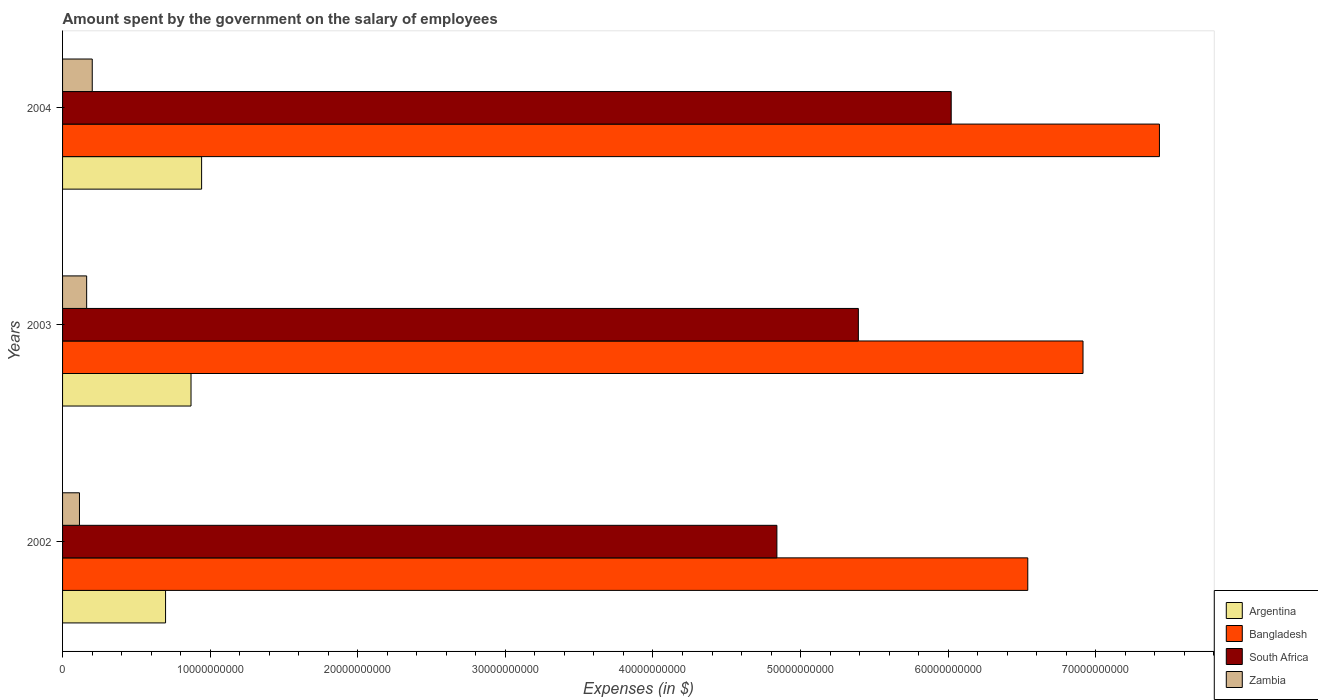How many groups of bars are there?
Keep it short and to the point. 3. Are the number of bars on each tick of the Y-axis equal?
Provide a short and direct response. Yes. How many bars are there on the 2nd tick from the bottom?
Your answer should be very brief. 4. In how many cases, is the number of bars for a given year not equal to the number of legend labels?
Offer a terse response. 0. What is the amount spent on the salary of employees by the government in Zambia in 2004?
Make the answer very short. 2.01e+09. Across all years, what is the maximum amount spent on the salary of employees by the government in Zambia?
Your answer should be very brief. 2.01e+09. Across all years, what is the minimum amount spent on the salary of employees by the government in Zambia?
Keep it short and to the point. 1.15e+09. In which year was the amount spent on the salary of employees by the government in South Africa maximum?
Provide a succinct answer. 2004. In which year was the amount spent on the salary of employees by the government in South Africa minimum?
Ensure brevity in your answer.  2002. What is the total amount spent on the salary of employees by the government in Argentina in the graph?
Your answer should be compact. 2.51e+1. What is the difference between the amount spent on the salary of employees by the government in Zambia in 2002 and that in 2003?
Your response must be concise. -4.87e+08. What is the difference between the amount spent on the salary of employees by the government in Argentina in 2004 and the amount spent on the salary of employees by the government in Zambia in 2002?
Your answer should be very brief. 8.27e+09. What is the average amount spent on the salary of employees by the government in Bangladesh per year?
Offer a terse response. 6.96e+1. In the year 2004, what is the difference between the amount spent on the salary of employees by the government in Zambia and amount spent on the salary of employees by the government in Argentina?
Your response must be concise. -7.41e+09. What is the ratio of the amount spent on the salary of employees by the government in South Africa in 2002 to that in 2004?
Provide a succinct answer. 0.8. What is the difference between the highest and the second highest amount spent on the salary of employees by the government in Argentina?
Your answer should be compact. 7.17e+08. What is the difference between the highest and the lowest amount spent on the salary of employees by the government in South Africa?
Keep it short and to the point. 1.18e+1. What does the 4th bar from the top in 2003 represents?
Provide a short and direct response. Argentina. What does the 1st bar from the bottom in 2004 represents?
Your answer should be compact. Argentina. Is it the case that in every year, the sum of the amount spent on the salary of employees by the government in Argentina and amount spent on the salary of employees by the government in South Africa is greater than the amount spent on the salary of employees by the government in Bangladesh?
Provide a succinct answer. No. How many bars are there?
Your response must be concise. 12. How many years are there in the graph?
Your answer should be very brief. 3. What is the difference between two consecutive major ticks on the X-axis?
Keep it short and to the point. 1.00e+1. Are the values on the major ticks of X-axis written in scientific E-notation?
Ensure brevity in your answer.  No. Does the graph contain any zero values?
Give a very brief answer. No. Does the graph contain grids?
Provide a short and direct response. No. How are the legend labels stacked?
Offer a terse response. Vertical. What is the title of the graph?
Your answer should be compact. Amount spent by the government on the salary of employees. Does "Guinea-Bissau" appear as one of the legend labels in the graph?
Your response must be concise. No. What is the label or title of the X-axis?
Provide a short and direct response. Expenses (in $). What is the Expenses (in $) in Argentina in 2002?
Provide a succinct answer. 6.98e+09. What is the Expenses (in $) of Bangladesh in 2002?
Provide a short and direct response. 6.54e+1. What is the Expenses (in $) in South Africa in 2002?
Offer a terse response. 4.84e+1. What is the Expenses (in $) in Zambia in 2002?
Give a very brief answer. 1.15e+09. What is the Expenses (in $) of Argentina in 2003?
Provide a short and direct response. 8.70e+09. What is the Expenses (in $) in Bangladesh in 2003?
Ensure brevity in your answer.  6.91e+1. What is the Expenses (in $) of South Africa in 2003?
Offer a very short reply. 5.39e+1. What is the Expenses (in $) in Zambia in 2003?
Make the answer very short. 1.63e+09. What is the Expenses (in $) in Argentina in 2004?
Your answer should be compact. 9.42e+09. What is the Expenses (in $) in Bangladesh in 2004?
Ensure brevity in your answer.  7.43e+1. What is the Expenses (in $) of South Africa in 2004?
Make the answer very short. 6.02e+1. What is the Expenses (in $) of Zambia in 2004?
Keep it short and to the point. 2.01e+09. Across all years, what is the maximum Expenses (in $) of Argentina?
Offer a very short reply. 9.42e+09. Across all years, what is the maximum Expenses (in $) of Bangladesh?
Ensure brevity in your answer.  7.43e+1. Across all years, what is the maximum Expenses (in $) in South Africa?
Give a very brief answer. 6.02e+1. Across all years, what is the maximum Expenses (in $) in Zambia?
Your answer should be very brief. 2.01e+09. Across all years, what is the minimum Expenses (in $) in Argentina?
Make the answer very short. 6.98e+09. Across all years, what is the minimum Expenses (in $) in Bangladesh?
Provide a short and direct response. 6.54e+1. Across all years, what is the minimum Expenses (in $) in South Africa?
Offer a very short reply. 4.84e+1. Across all years, what is the minimum Expenses (in $) in Zambia?
Ensure brevity in your answer.  1.15e+09. What is the total Expenses (in $) in Argentina in the graph?
Offer a terse response. 2.51e+1. What is the total Expenses (in $) of Bangladesh in the graph?
Provide a succinct answer. 2.09e+11. What is the total Expenses (in $) in South Africa in the graph?
Make the answer very short. 1.63e+11. What is the total Expenses (in $) of Zambia in the graph?
Give a very brief answer. 4.79e+09. What is the difference between the Expenses (in $) of Argentina in 2002 and that in 2003?
Offer a terse response. -1.72e+09. What is the difference between the Expenses (in $) in Bangladesh in 2002 and that in 2003?
Keep it short and to the point. -3.74e+09. What is the difference between the Expenses (in $) of South Africa in 2002 and that in 2003?
Keep it short and to the point. -5.52e+09. What is the difference between the Expenses (in $) of Zambia in 2002 and that in 2003?
Provide a short and direct response. -4.87e+08. What is the difference between the Expenses (in $) in Argentina in 2002 and that in 2004?
Your answer should be compact. -2.44e+09. What is the difference between the Expenses (in $) of Bangladesh in 2002 and that in 2004?
Provide a short and direct response. -8.92e+09. What is the difference between the Expenses (in $) of South Africa in 2002 and that in 2004?
Provide a short and direct response. -1.18e+1. What is the difference between the Expenses (in $) of Zambia in 2002 and that in 2004?
Offer a very short reply. -8.65e+08. What is the difference between the Expenses (in $) of Argentina in 2003 and that in 2004?
Provide a short and direct response. -7.17e+08. What is the difference between the Expenses (in $) of Bangladesh in 2003 and that in 2004?
Offer a very short reply. -5.18e+09. What is the difference between the Expenses (in $) in South Africa in 2003 and that in 2004?
Your answer should be compact. -6.29e+09. What is the difference between the Expenses (in $) in Zambia in 2003 and that in 2004?
Provide a succinct answer. -3.78e+08. What is the difference between the Expenses (in $) in Argentina in 2002 and the Expenses (in $) in Bangladesh in 2003?
Ensure brevity in your answer.  -6.22e+1. What is the difference between the Expenses (in $) of Argentina in 2002 and the Expenses (in $) of South Africa in 2003?
Offer a terse response. -4.69e+1. What is the difference between the Expenses (in $) of Argentina in 2002 and the Expenses (in $) of Zambia in 2003?
Offer a terse response. 5.35e+09. What is the difference between the Expenses (in $) in Bangladesh in 2002 and the Expenses (in $) in South Africa in 2003?
Give a very brief answer. 1.15e+1. What is the difference between the Expenses (in $) of Bangladesh in 2002 and the Expenses (in $) of Zambia in 2003?
Give a very brief answer. 6.38e+1. What is the difference between the Expenses (in $) of South Africa in 2002 and the Expenses (in $) of Zambia in 2003?
Ensure brevity in your answer.  4.68e+1. What is the difference between the Expenses (in $) of Argentina in 2002 and the Expenses (in $) of Bangladesh in 2004?
Your response must be concise. -6.73e+1. What is the difference between the Expenses (in $) in Argentina in 2002 and the Expenses (in $) in South Africa in 2004?
Give a very brief answer. -5.32e+1. What is the difference between the Expenses (in $) in Argentina in 2002 and the Expenses (in $) in Zambia in 2004?
Ensure brevity in your answer.  4.97e+09. What is the difference between the Expenses (in $) in Bangladesh in 2002 and the Expenses (in $) in South Africa in 2004?
Your answer should be very brief. 5.19e+09. What is the difference between the Expenses (in $) of Bangladesh in 2002 and the Expenses (in $) of Zambia in 2004?
Provide a short and direct response. 6.34e+1. What is the difference between the Expenses (in $) in South Africa in 2002 and the Expenses (in $) in Zambia in 2004?
Keep it short and to the point. 4.64e+1. What is the difference between the Expenses (in $) in Argentina in 2003 and the Expenses (in $) in Bangladesh in 2004?
Keep it short and to the point. -6.56e+1. What is the difference between the Expenses (in $) in Argentina in 2003 and the Expenses (in $) in South Africa in 2004?
Offer a very short reply. -5.15e+1. What is the difference between the Expenses (in $) of Argentina in 2003 and the Expenses (in $) of Zambia in 2004?
Your answer should be compact. 6.69e+09. What is the difference between the Expenses (in $) in Bangladesh in 2003 and the Expenses (in $) in South Africa in 2004?
Your answer should be very brief. 8.93e+09. What is the difference between the Expenses (in $) in Bangladesh in 2003 and the Expenses (in $) in Zambia in 2004?
Your answer should be very brief. 6.71e+1. What is the difference between the Expenses (in $) of South Africa in 2003 and the Expenses (in $) of Zambia in 2004?
Your response must be concise. 5.19e+1. What is the average Expenses (in $) in Argentina per year?
Provide a succinct answer. 8.37e+09. What is the average Expenses (in $) of Bangladesh per year?
Your response must be concise. 6.96e+1. What is the average Expenses (in $) of South Africa per year?
Your response must be concise. 5.42e+1. What is the average Expenses (in $) of Zambia per year?
Make the answer very short. 1.60e+09. In the year 2002, what is the difference between the Expenses (in $) of Argentina and Expenses (in $) of Bangladesh?
Ensure brevity in your answer.  -5.84e+1. In the year 2002, what is the difference between the Expenses (in $) of Argentina and Expenses (in $) of South Africa?
Your answer should be compact. -4.14e+1. In the year 2002, what is the difference between the Expenses (in $) in Argentina and Expenses (in $) in Zambia?
Provide a succinct answer. 5.83e+09. In the year 2002, what is the difference between the Expenses (in $) of Bangladesh and Expenses (in $) of South Africa?
Ensure brevity in your answer.  1.70e+1. In the year 2002, what is the difference between the Expenses (in $) in Bangladesh and Expenses (in $) in Zambia?
Keep it short and to the point. 6.42e+1. In the year 2002, what is the difference between the Expenses (in $) in South Africa and Expenses (in $) in Zambia?
Your response must be concise. 4.73e+1. In the year 2003, what is the difference between the Expenses (in $) of Argentina and Expenses (in $) of Bangladesh?
Your response must be concise. -6.04e+1. In the year 2003, what is the difference between the Expenses (in $) in Argentina and Expenses (in $) in South Africa?
Your response must be concise. -4.52e+1. In the year 2003, what is the difference between the Expenses (in $) of Argentina and Expenses (in $) of Zambia?
Offer a very short reply. 7.07e+09. In the year 2003, what is the difference between the Expenses (in $) in Bangladesh and Expenses (in $) in South Africa?
Make the answer very short. 1.52e+1. In the year 2003, what is the difference between the Expenses (in $) of Bangladesh and Expenses (in $) of Zambia?
Give a very brief answer. 6.75e+1. In the year 2003, what is the difference between the Expenses (in $) of South Africa and Expenses (in $) of Zambia?
Ensure brevity in your answer.  5.23e+1. In the year 2004, what is the difference between the Expenses (in $) in Argentina and Expenses (in $) in Bangladesh?
Provide a short and direct response. -6.49e+1. In the year 2004, what is the difference between the Expenses (in $) of Argentina and Expenses (in $) of South Africa?
Ensure brevity in your answer.  -5.08e+1. In the year 2004, what is the difference between the Expenses (in $) of Argentina and Expenses (in $) of Zambia?
Give a very brief answer. 7.41e+09. In the year 2004, what is the difference between the Expenses (in $) in Bangladesh and Expenses (in $) in South Africa?
Offer a very short reply. 1.41e+1. In the year 2004, what is the difference between the Expenses (in $) of Bangladesh and Expenses (in $) of Zambia?
Offer a very short reply. 7.23e+1. In the year 2004, what is the difference between the Expenses (in $) of South Africa and Expenses (in $) of Zambia?
Your response must be concise. 5.82e+1. What is the ratio of the Expenses (in $) of Argentina in 2002 to that in 2003?
Keep it short and to the point. 0.8. What is the ratio of the Expenses (in $) in Bangladesh in 2002 to that in 2003?
Your answer should be compact. 0.95. What is the ratio of the Expenses (in $) of South Africa in 2002 to that in 2003?
Keep it short and to the point. 0.9. What is the ratio of the Expenses (in $) in Zambia in 2002 to that in 2003?
Offer a terse response. 0.7. What is the ratio of the Expenses (in $) of Argentina in 2002 to that in 2004?
Offer a terse response. 0.74. What is the ratio of the Expenses (in $) in Bangladesh in 2002 to that in 2004?
Provide a short and direct response. 0.88. What is the ratio of the Expenses (in $) of South Africa in 2002 to that in 2004?
Ensure brevity in your answer.  0.8. What is the ratio of the Expenses (in $) of Zambia in 2002 to that in 2004?
Ensure brevity in your answer.  0.57. What is the ratio of the Expenses (in $) of Argentina in 2003 to that in 2004?
Your answer should be very brief. 0.92. What is the ratio of the Expenses (in $) in Bangladesh in 2003 to that in 2004?
Provide a short and direct response. 0.93. What is the ratio of the Expenses (in $) in South Africa in 2003 to that in 2004?
Your answer should be compact. 0.9. What is the ratio of the Expenses (in $) in Zambia in 2003 to that in 2004?
Offer a terse response. 0.81. What is the difference between the highest and the second highest Expenses (in $) of Argentina?
Offer a very short reply. 7.17e+08. What is the difference between the highest and the second highest Expenses (in $) in Bangladesh?
Your answer should be very brief. 5.18e+09. What is the difference between the highest and the second highest Expenses (in $) of South Africa?
Provide a short and direct response. 6.29e+09. What is the difference between the highest and the second highest Expenses (in $) in Zambia?
Your answer should be very brief. 3.78e+08. What is the difference between the highest and the lowest Expenses (in $) in Argentina?
Keep it short and to the point. 2.44e+09. What is the difference between the highest and the lowest Expenses (in $) of Bangladesh?
Offer a very short reply. 8.92e+09. What is the difference between the highest and the lowest Expenses (in $) of South Africa?
Give a very brief answer. 1.18e+1. What is the difference between the highest and the lowest Expenses (in $) of Zambia?
Your answer should be very brief. 8.65e+08. 